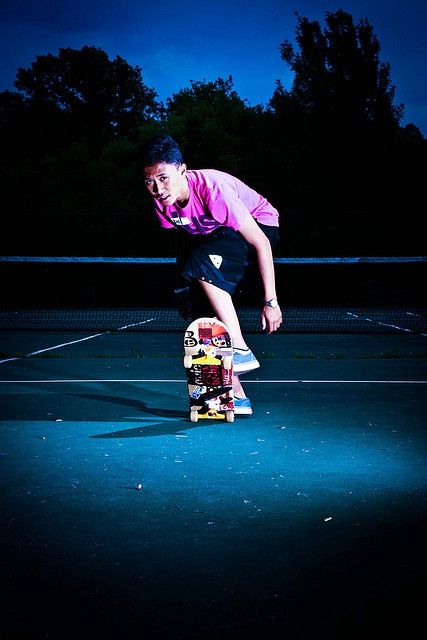Describe the objects in this image and their specific colors. I can see people in navy, black, lavender, and violet tones and skateboard in navy, black, white, darkgray, and lightpink tones in this image. 